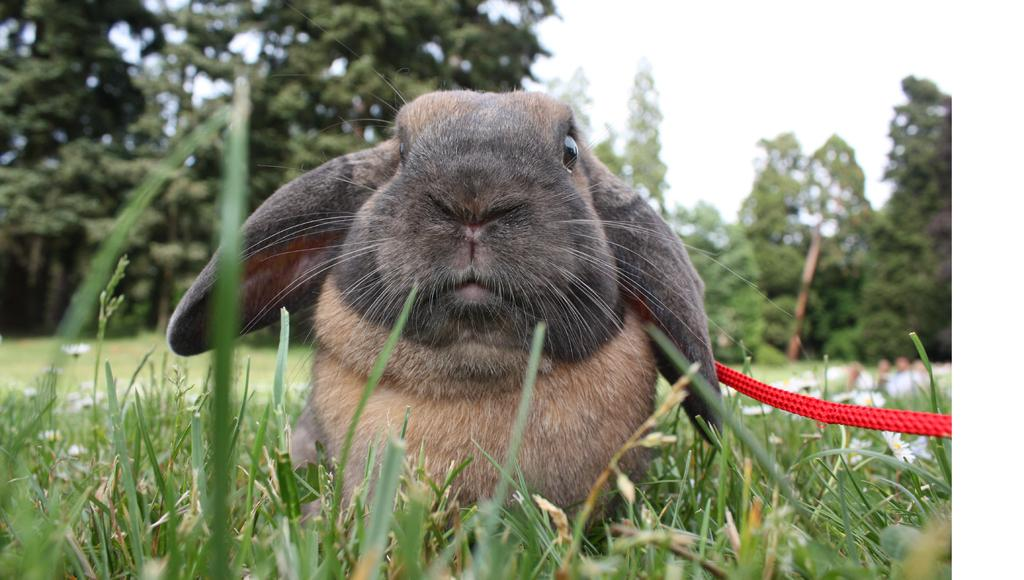What animal is present in the image? There is a rabbit in the image. What is the rabbit standing on? The rabbit is on a grass surface. Is there anything attached to the rabbit? Yes, a red color rope is tied to the rabbit. What can be seen in the background of the image? There are trees and the sky visible in the background of the image. What type of news can be heard from the plane in the image? There is no plane present in the image, so there is no news to be heard. Can you see any cracks in the image? There is no mention of any cracks in the provided facts, so we cannot determine if any are present in the image. 